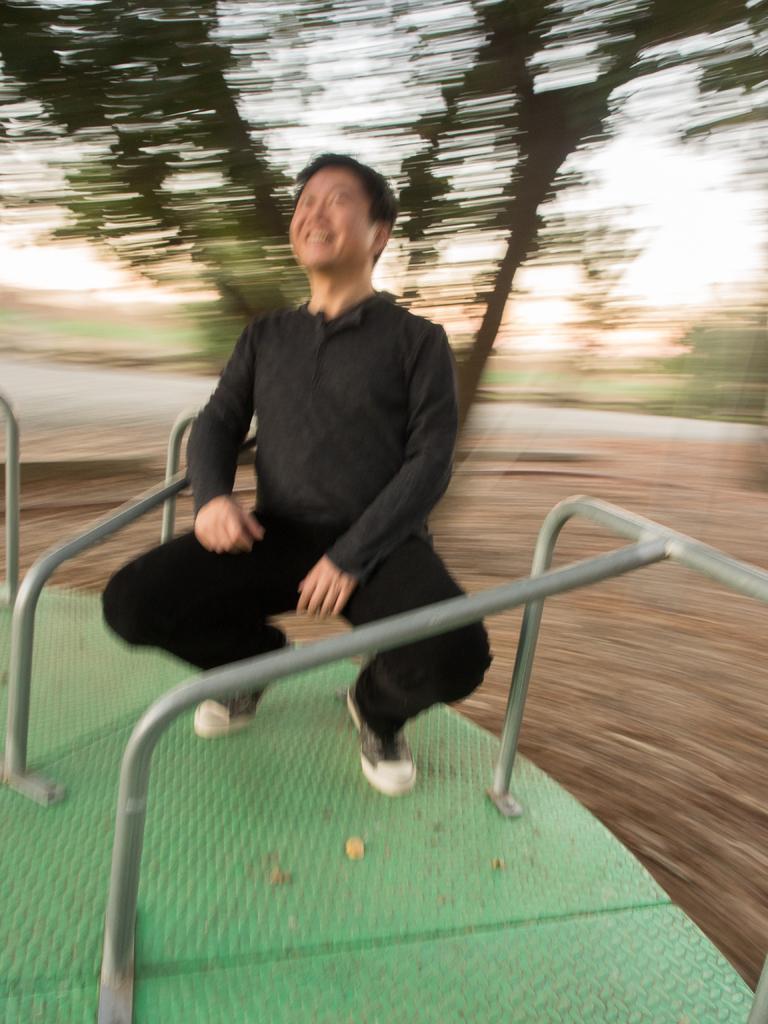How would you summarize this image in a sentence or two? In the image we can see a person sitting in a squat position. Here we can see a metal object. And the background is blurred. 